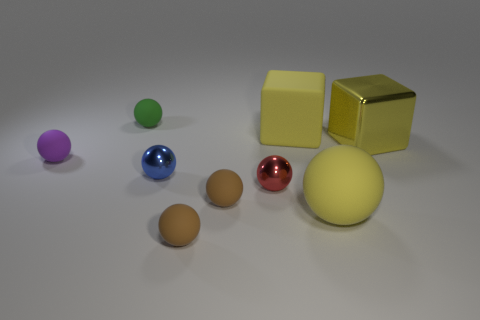What number of matte spheres are both to the right of the red ball and on the left side of the blue ball?
Provide a short and direct response. 0. There is a yellow thing in front of the blue metal sphere; what is it made of?
Give a very brief answer. Rubber. What size is the cube that is the same material as the tiny blue object?
Keep it short and to the point. Large. There is a red object; are there any small spheres right of it?
Provide a succinct answer. No. What is the size of the matte thing that is the same shape as the yellow metal object?
Ensure brevity in your answer.  Large. There is a big matte cube; is it the same color as the tiny ball in front of the big rubber sphere?
Keep it short and to the point. No. Is the color of the shiny cube the same as the matte cube?
Your response must be concise. Yes. Is the number of purple things less than the number of big green matte objects?
Your answer should be compact. No. How many other objects are there of the same color as the metallic cube?
Your answer should be very brief. 2. How many brown rubber things are there?
Provide a succinct answer. 2. 